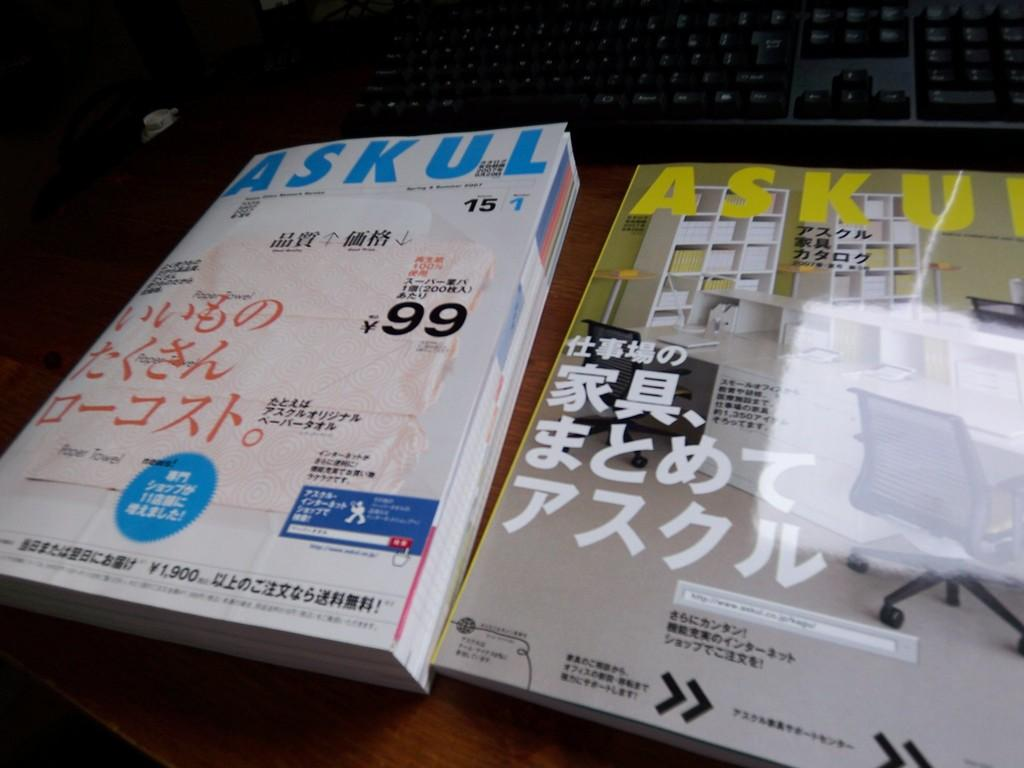What objects are on the table in the image? There are two books on a table in the image. What is located behind the books on the table? There is a keyboard behind the books in the image. How many bananas are on the keyboard in the image? There are no bananas present in the image. What is the reason for the books being on the table in the image? The image does not provide information about the reason for the books being on the table. 